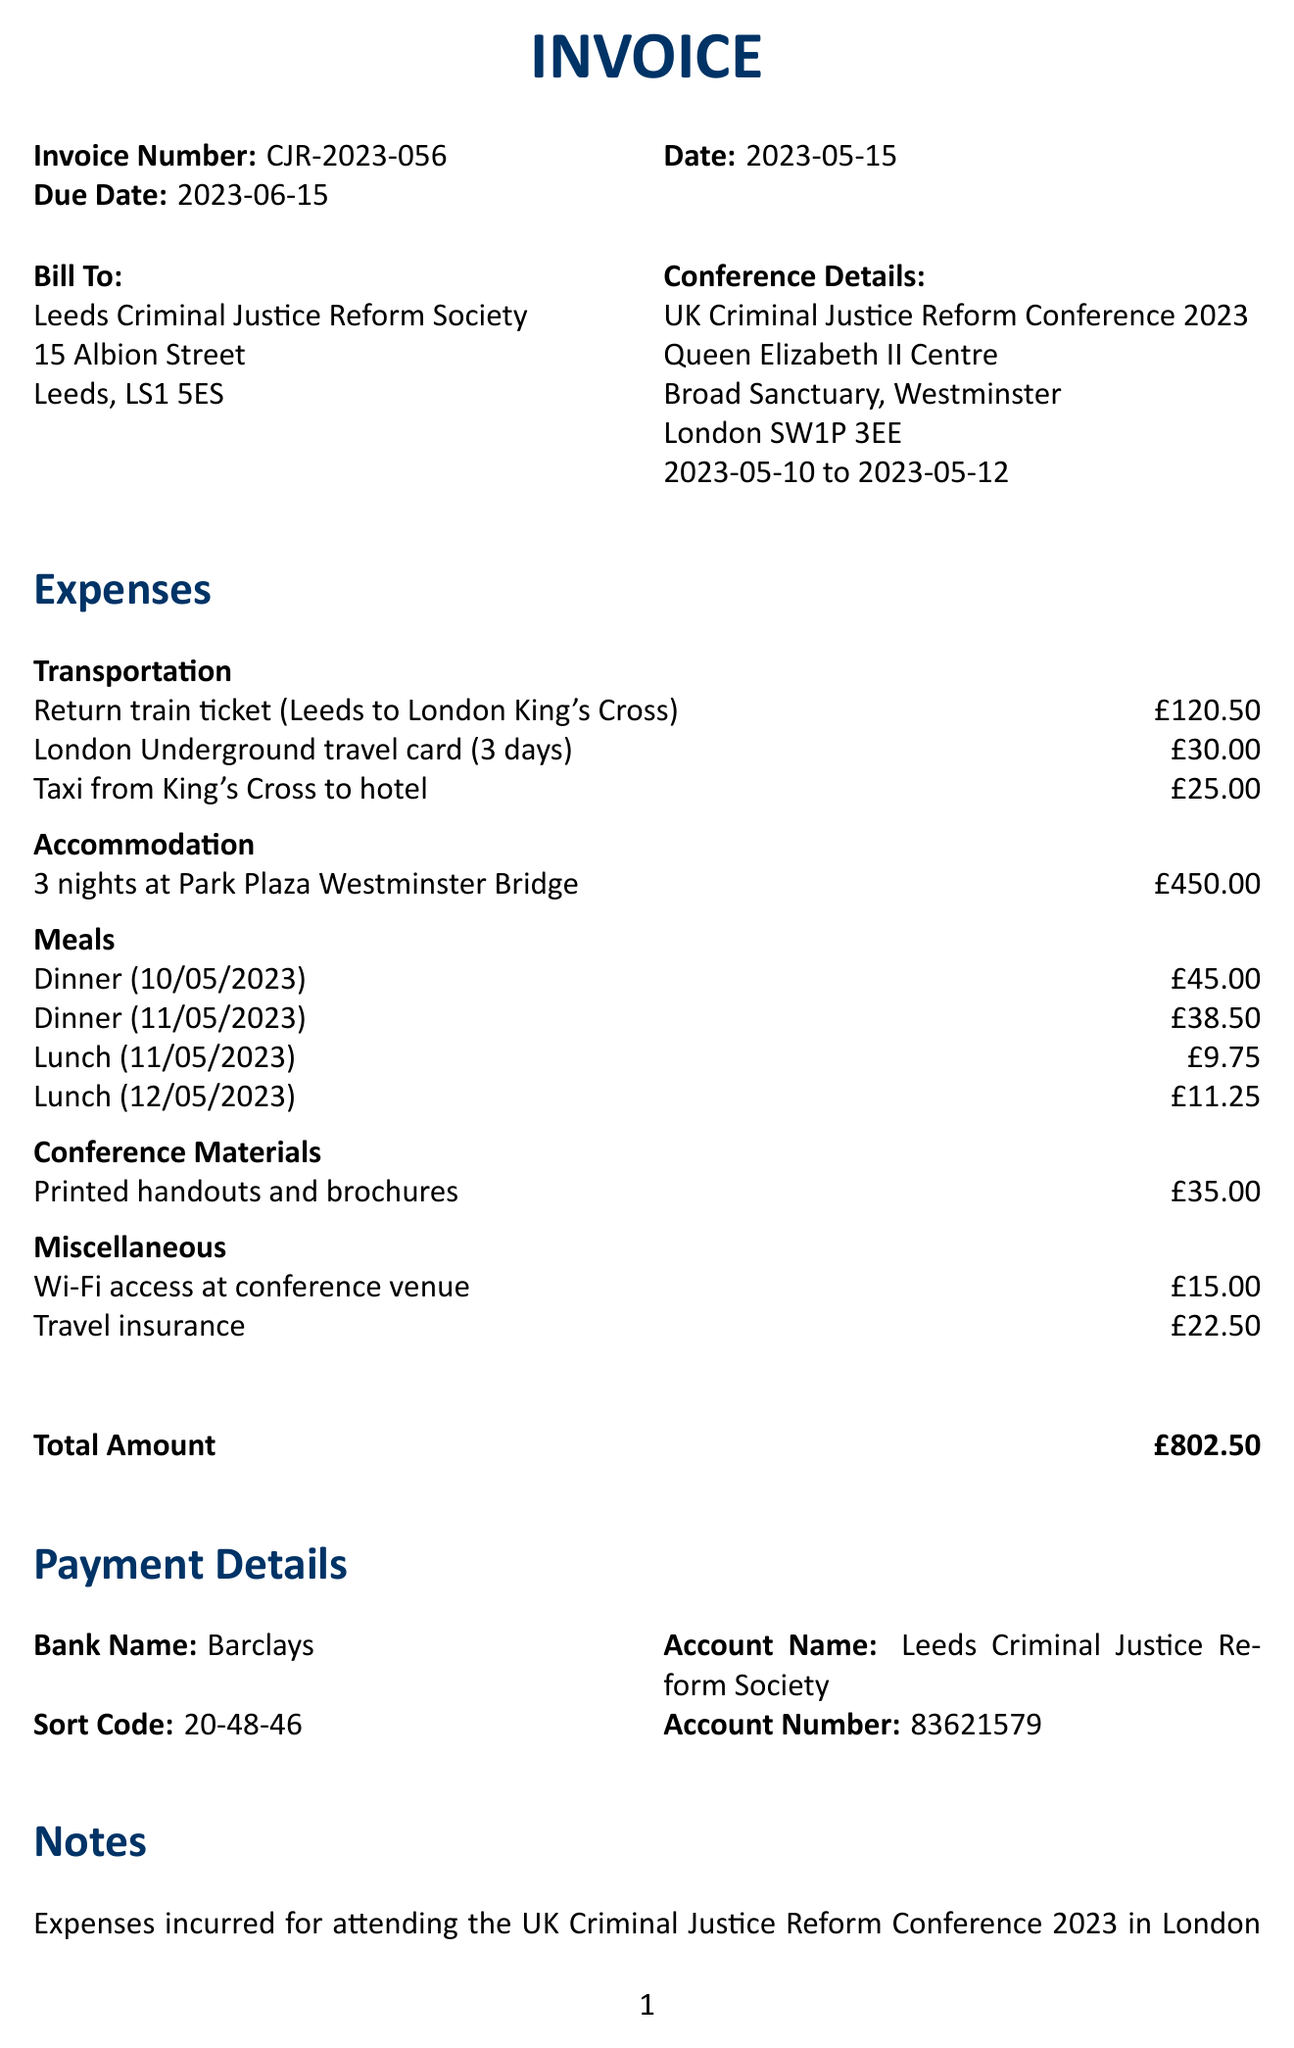What is the invoice number? The invoice number is a unique identifier for the document, specified in the invoice details.
Answer: CJR-2023-056 What is the date of the invoice? The date of the invoice indicates when it was issued, as shown in the invoice details.
Answer: 2023-05-15 What is the total amount of travel expenses? The total amount reflects the overall expenses incurred, detailed at the end of the document.
Answer: £802.50 What is the date range of the conference? The date range indicates the period during which the conference takes place, listed in the conference details.
Answer: 2023-05-10 to 2023-05-12 Which provider was used for the return train ticket? The provider for the train ticket is specified within the travel expenses category.
Answer: LNER What category does the dinner from Dishoom Covent Garden fall under? This question pertains to the type of expense associated with dining, categorized in the document.
Answer: Meals What is the payment method for the invoice? This question seeks the details regarding the bank information included for payment processing.
Answer: Bank transfer What was the accommodation expense? The accommodation expense shows the cost for lodging during the conference, specified under the accommodation category.
Answer: £450.00 What is mentioned in the notes section? The notes section provides context and clarification on the purpose of the expenses incurred during the conference.
Answer: Expenses incurred for attending the UK Criminal Justice Reform Conference 2023 in London as a representative of the Leeds Criminal Justice Reform Society. All receipts are attached for reference 